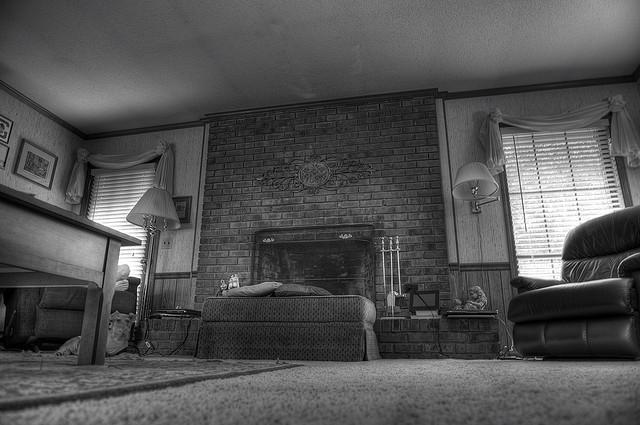How many lamps are there?
Give a very brief answer. 2. How many couches are there?
Give a very brief answer. 3. How many boats are not docked in this scene?
Give a very brief answer. 0. 